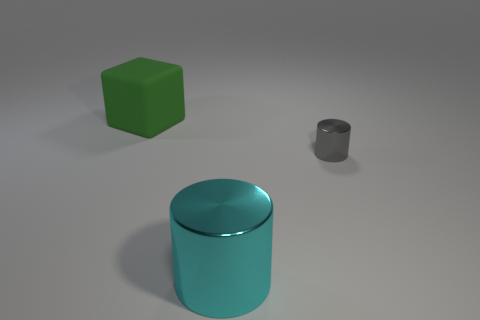What is the color of the big thing right of the big green cube? The object to the right of the big green cube is a large cylinder, and it has a glossy cyan color. 